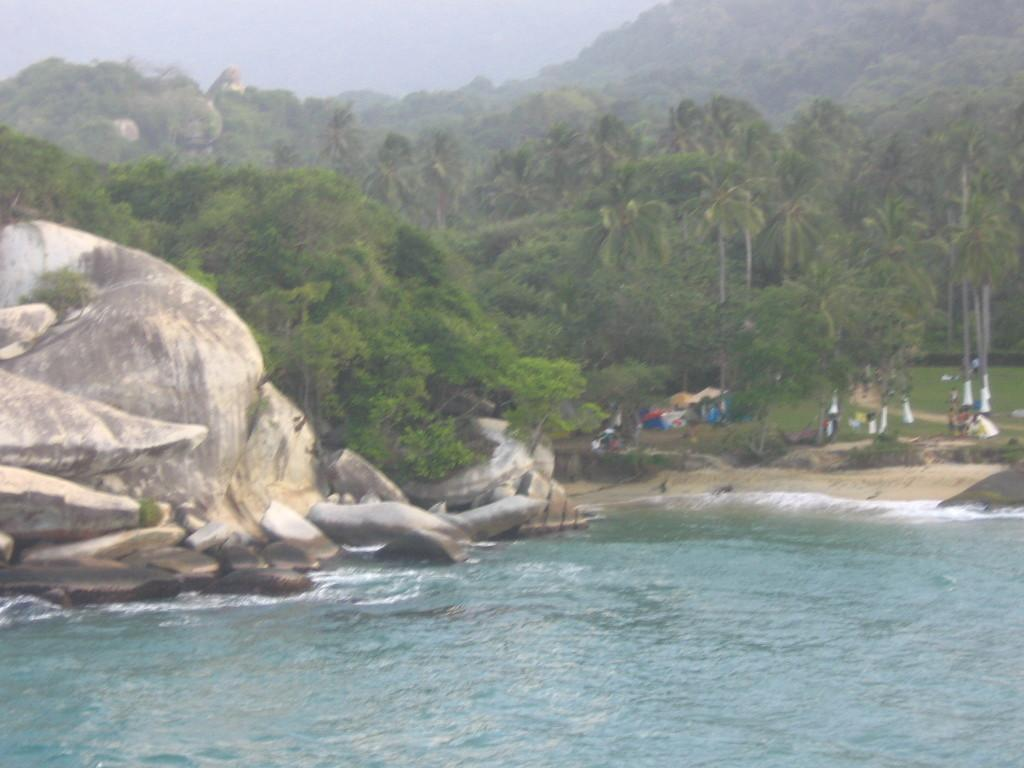What is the primary element in the image? There is water in the image. What other natural elements can be seen in the image? There are rocks and trees visible in the image. What can be seen in the background of the image? In the background, there are people, grass, tents, and the sky visible. How many shelves are visible in the image? There are no shelves present in the image. 